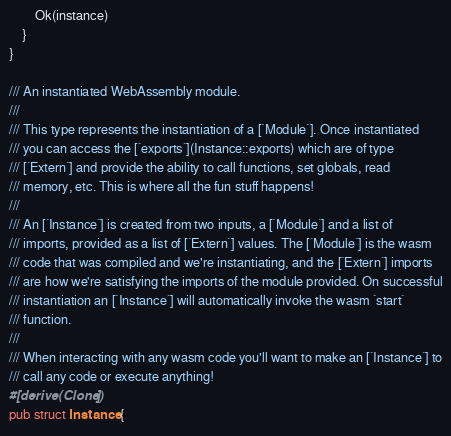<code> <loc_0><loc_0><loc_500><loc_500><_Rust_>        Ok(instance)
    }
}

/// An instantiated WebAssembly module.
///
/// This type represents the instantiation of a [`Module`]. Once instantiated
/// you can access the [`exports`](Instance::exports) which are of type
/// [`Extern`] and provide the ability to call functions, set globals, read
/// memory, etc. This is where all the fun stuff happens!
///
/// An [`Instance`] is created from two inputs, a [`Module`] and a list of
/// imports, provided as a list of [`Extern`] values. The [`Module`] is the wasm
/// code that was compiled and we're instantiating, and the [`Extern`] imports
/// are how we're satisfying the imports of the module provided. On successful
/// instantiation an [`Instance`] will automatically invoke the wasm `start`
/// function.
///
/// When interacting with any wasm code you'll want to make an [`Instance`] to
/// call any code or execute anything!
#[derive(Clone)]
pub struct Instance {</code> 